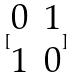Convert formula to latex. <formula><loc_0><loc_0><loc_500><loc_500>[ \begin{matrix} 0 & 1 \\ 1 & 0 \end{matrix} ]</formula> 